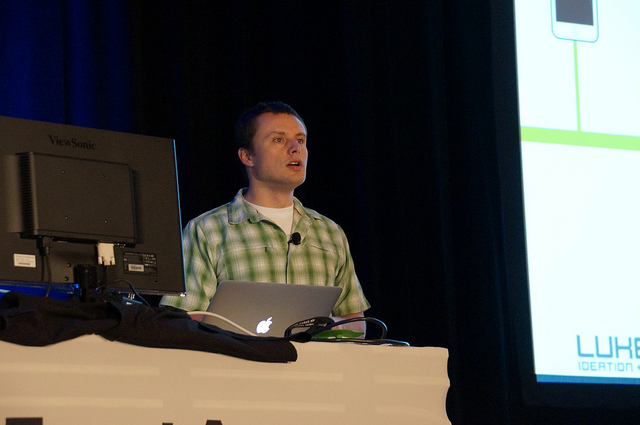<image>What is the man demonstrating? The man could be demonstrating a range of things, including a phone, program, powerpoint, or technology. It is unknown without more specific information. What is the man demonstrating? I am not sure what the man is demonstrating. It can be seen that he is demonstrating about phone, program, or iphone. 